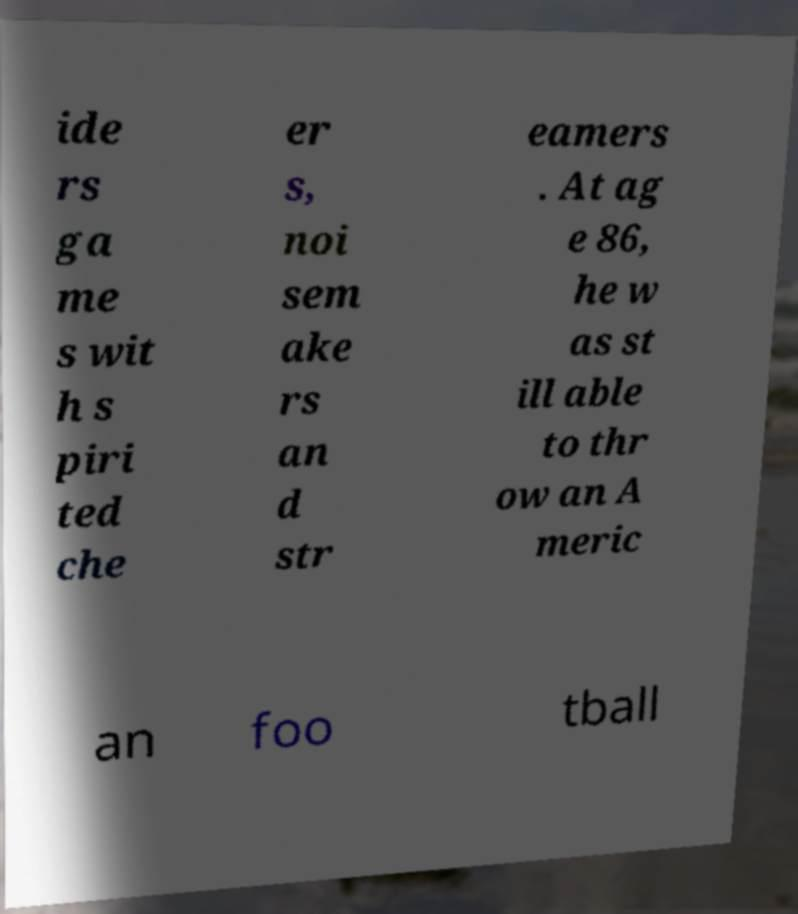Please identify and transcribe the text found in this image. ide rs ga me s wit h s piri ted che er s, noi sem ake rs an d str eamers . At ag e 86, he w as st ill able to thr ow an A meric an foo tball 